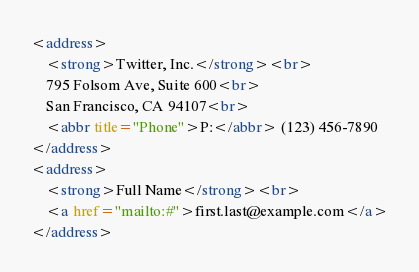<code> <loc_0><loc_0><loc_500><loc_500><_HTML_><address>
    <strong>Twitter, Inc.</strong><br>
    795 Folsom Ave, Suite 600<br>
    San Francisco, CA 94107<br>
    <abbr title="Phone">P:</abbr> (123) 456-7890
</address>
<address>
    <strong>Full Name</strong><br>
    <a href="mailto:#">first.last@example.com</a>
</address></code> 